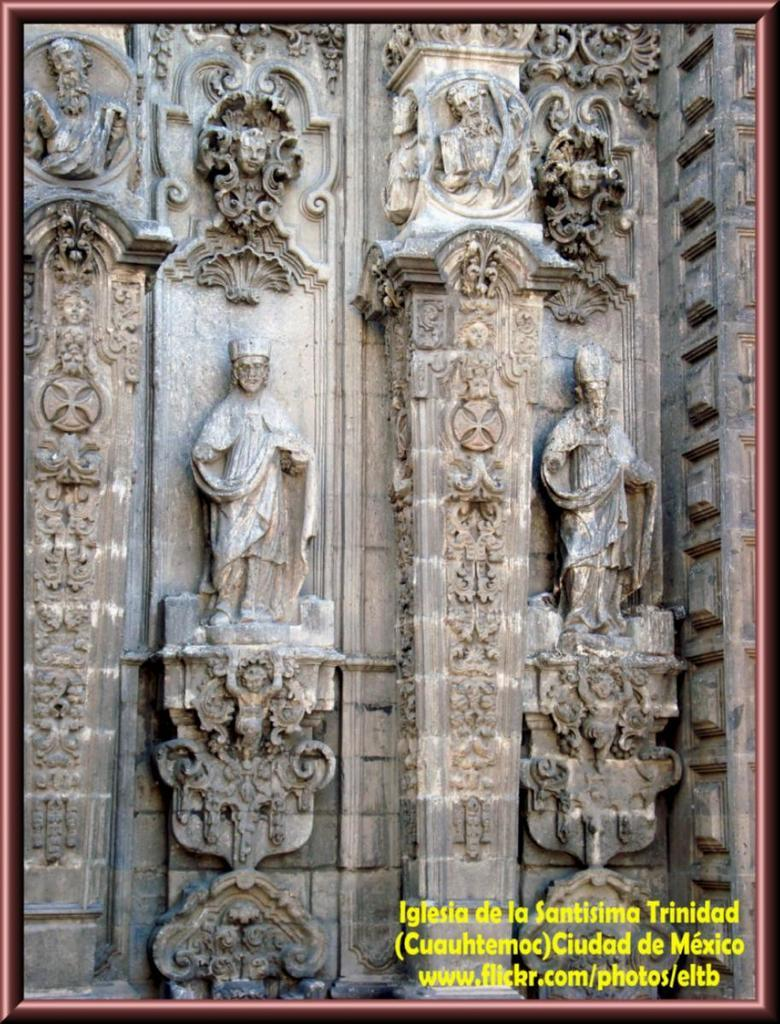What can be seen in the image besides text? There are sculptures in the image. Where is the text located in the image? The text is written in the bottom right of the image. What type of crook is depicted in the sculpture? There is no crook depicted in the sculpture; the image only shows sculptures and text. How many drops of water can be seen falling from the sculpture? There are no drops of water present in the image; it only features sculptures and text. 